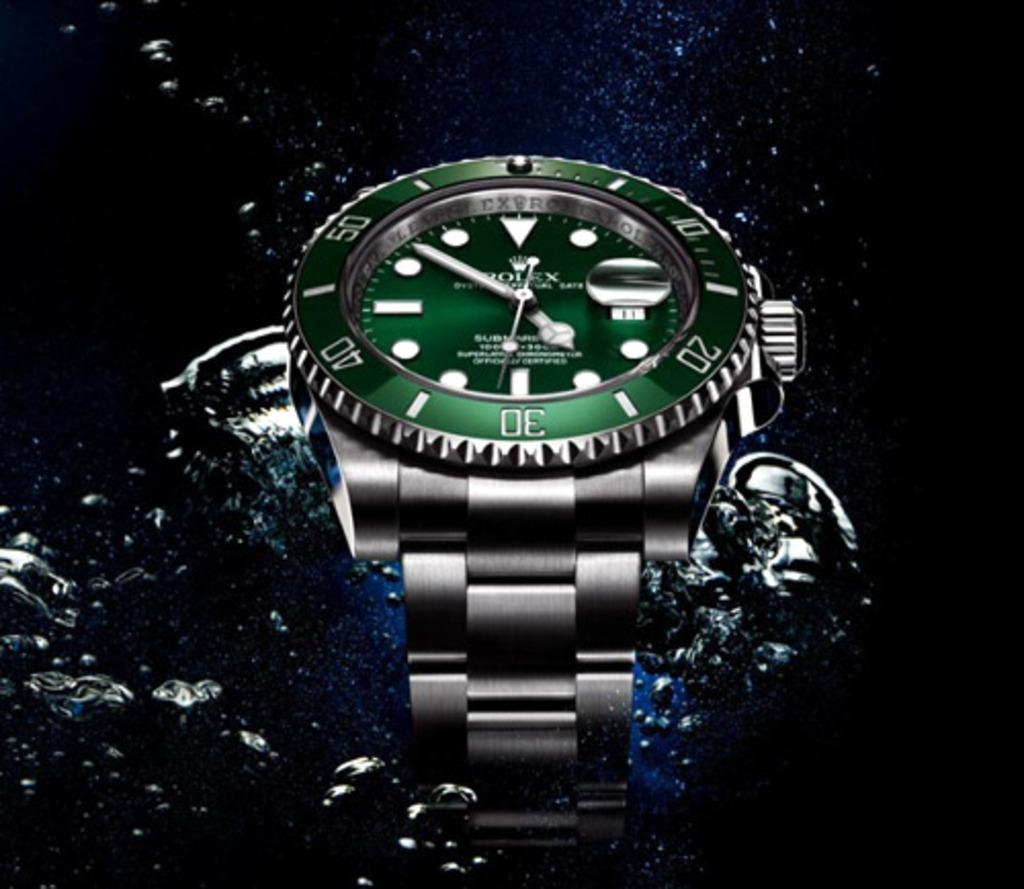What object is in the image? There is a watch in the image. Where is the watch located? The watch is on the water. What can be observed about the background of the image? The background of the image is dark. What type of education does the minister receive in the image? There is no minister or education present in the image; it only features a watch on the water. Can you tell me how many toads are visible in the image? There are no toads present in the image. 